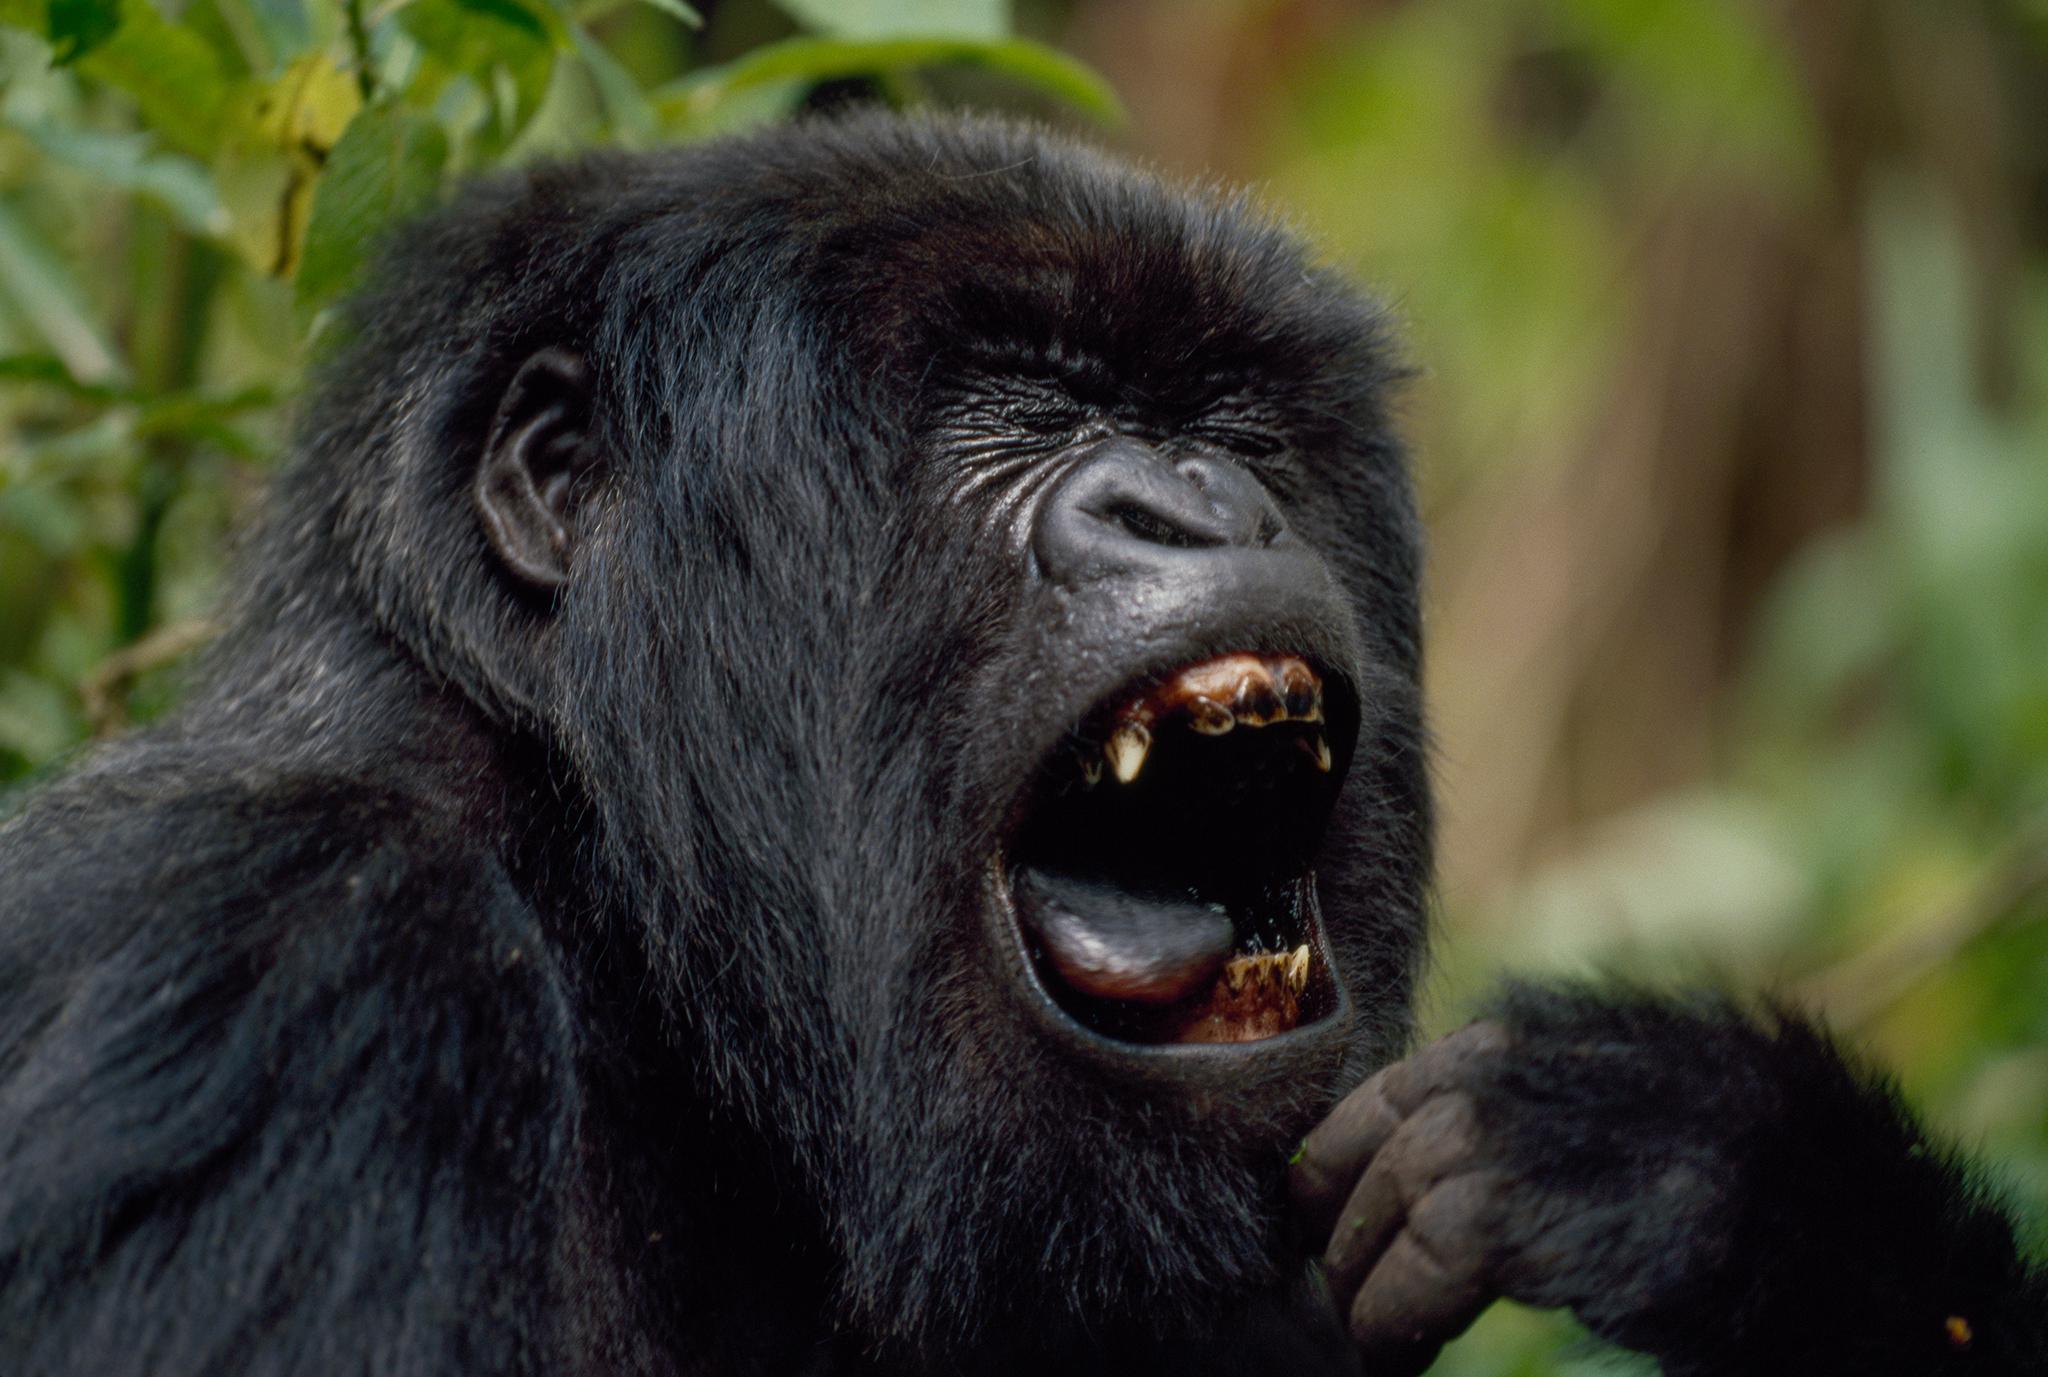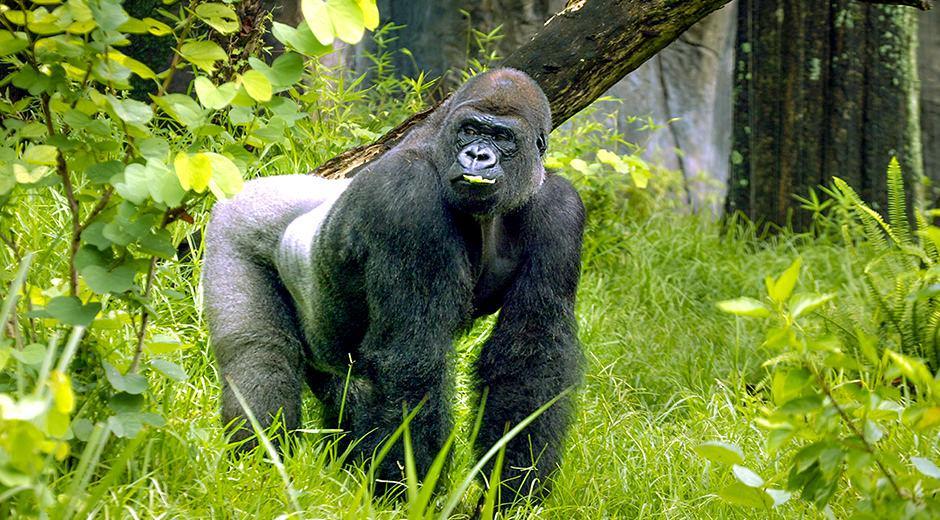The first image is the image on the left, the second image is the image on the right. Analyze the images presented: Is the assertion "The right image contains two gorillas." valid? Answer yes or no. No. The first image is the image on the left, the second image is the image on the right. Analyze the images presented: Is the assertion "The left image features an adult male gorilla clutching a leafy green item near its mouth." valid? Answer yes or no. No. 